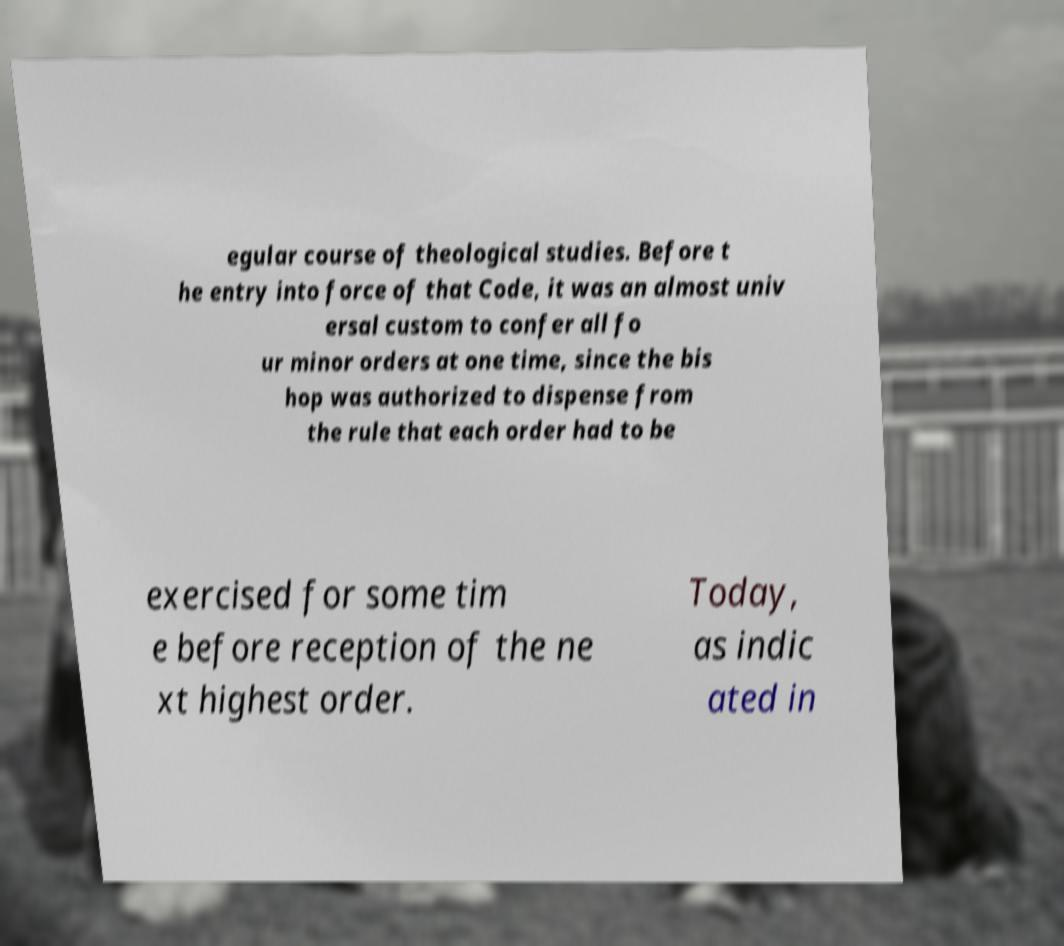What messages or text are displayed in this image? I need them in a readable, typed format. egular course of theological studies. Before t he entry into force of that Code, it was an almost univ ersal custom to confer all fo ur minor orders at one time, since the bis hop was authorized to dispense from the rule that each order had to be exercised for some tim e before reception of the ne xt highest order. Today, as indic ated in 